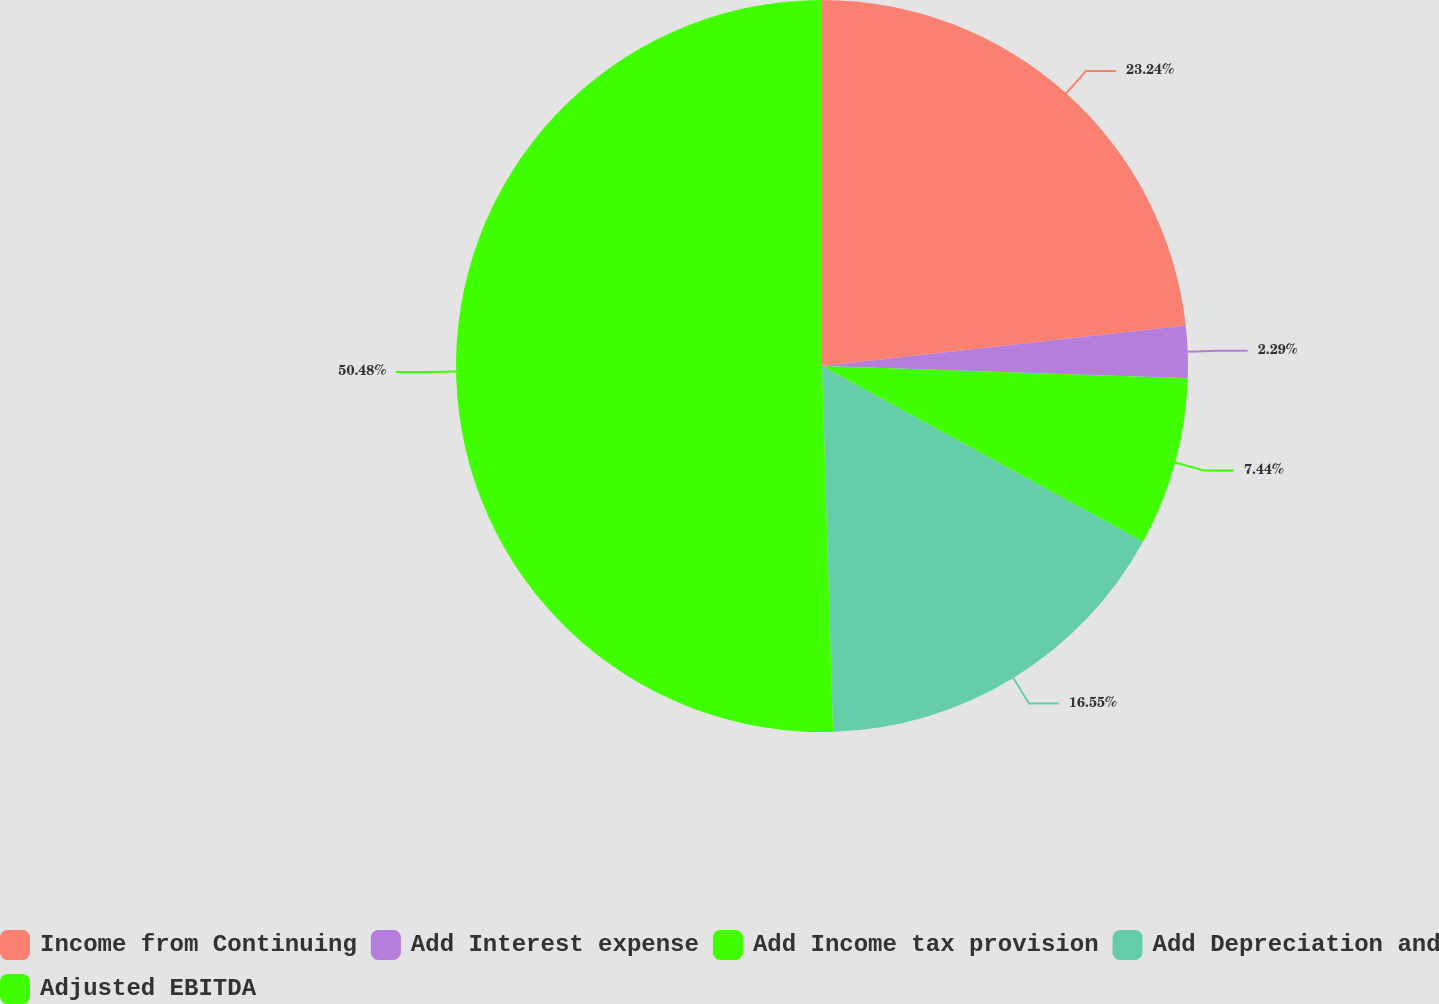<chart> <loc_0><loc_0><loc_500><loc_500><pie_chart><fcel>Income from Continuing<fcel>Add Interest expense<fcel>Add Income tax provision<fcel>Add Depreciation and<fcel>Adjusted EBITDA<nl><fcel>23.24%<fcel>2.29%<fcel>7.44%<fcel>16.55%<fcel>50.48%<nl></chart> 